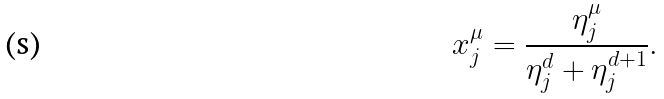Convert formula to latex. <formula><loc_0><loc_0><loc_500><loc_500>x _ { j } ^ { \mu } = \frac { \eta _ { j } ^ { \mu } } { \eta _ { j } ^ { d } + \eta _ { j } ^ { d + 1 } } .</formula> 